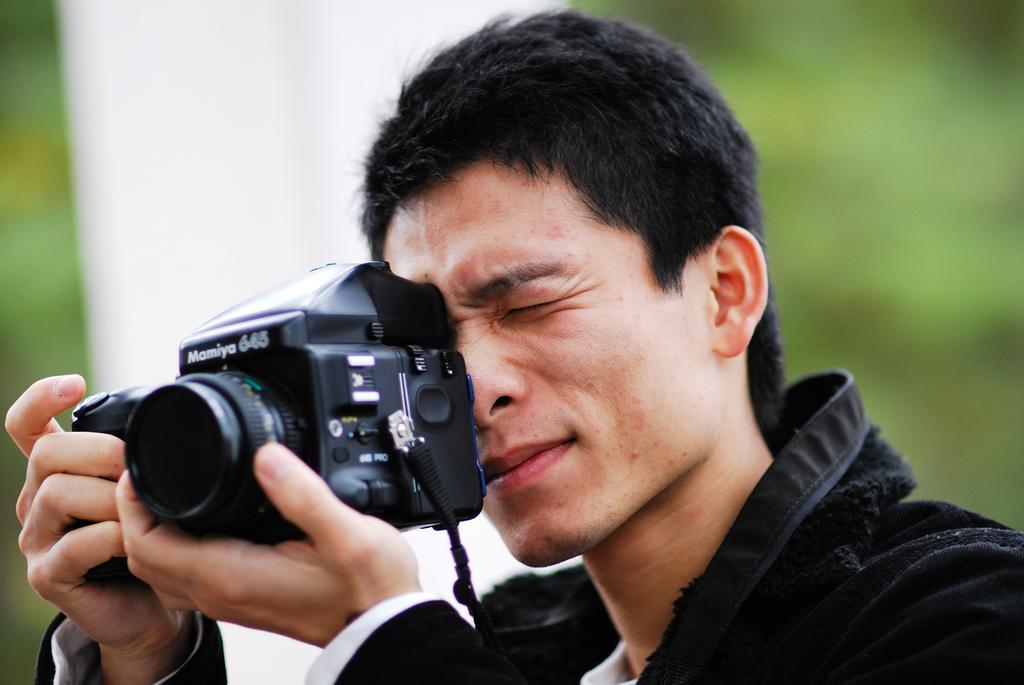Could you give a brief overview of what you see in this image? A man is taking picture with a camera in his hand. 